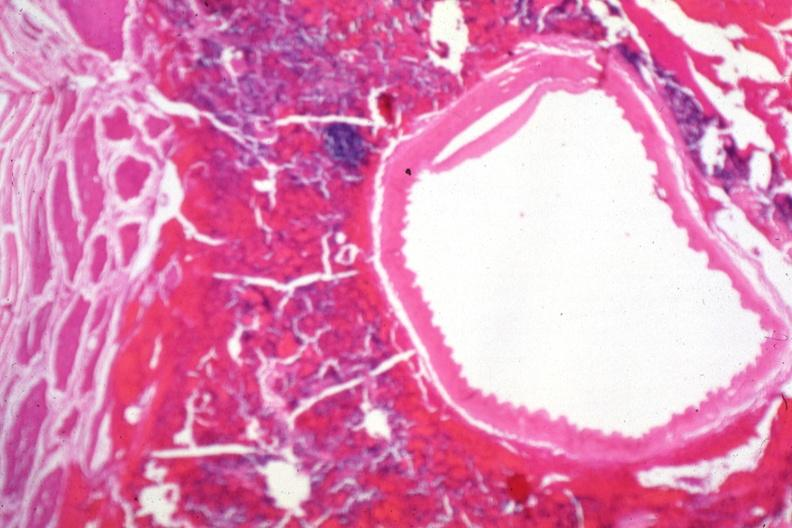s malignant lymphoma present?
Answer the question using a single word or phrase. No 